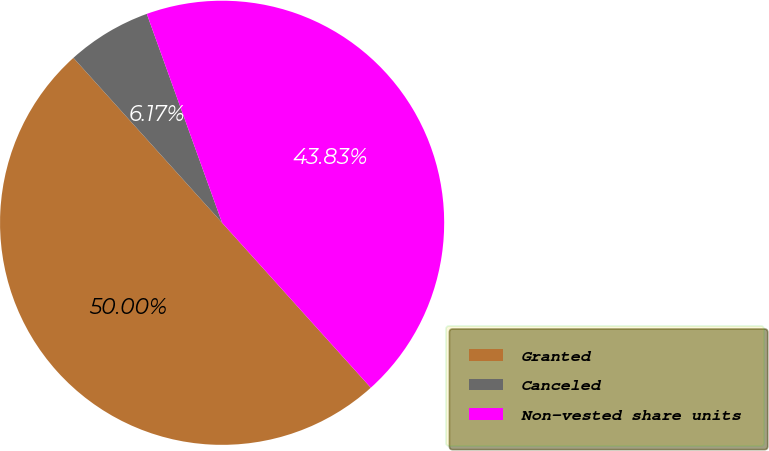Convert chart. <chart><loc_0><loc_0><loc_500><loc_500><pie_chart><fcel>Granted<fcel>Canceled<fcel>Non-vested share units<nl><fcel>50.0%<fcel>6.17%<fcel>43.83%<nl></chart> 